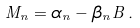Convert formula to latex. <formula><loc_0><loc_0><loc_500><loc_500>M _ { n } = \alpha _ { n } - \beta _ { n } B \, .</formula> 